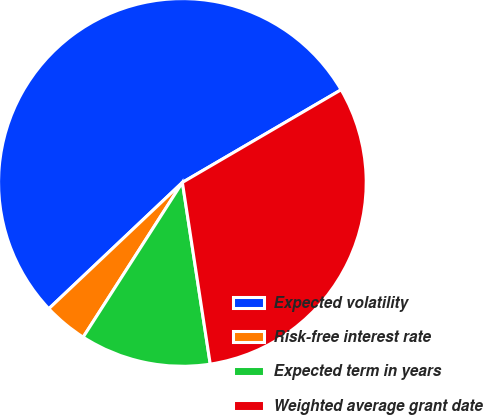Convert chart to OTSL. <chart><loc_0><loc_0><loc_500><loc_500><pie_chart><fcel>Expected volatility<fcel>Risk-free interest rate<fcel>Expected term in years<fcel>Weighted average grant date<nl><fcel>53.65%<fcel>3.87%<fcel>11.5%<fcel>30.99%<nl></chart> 